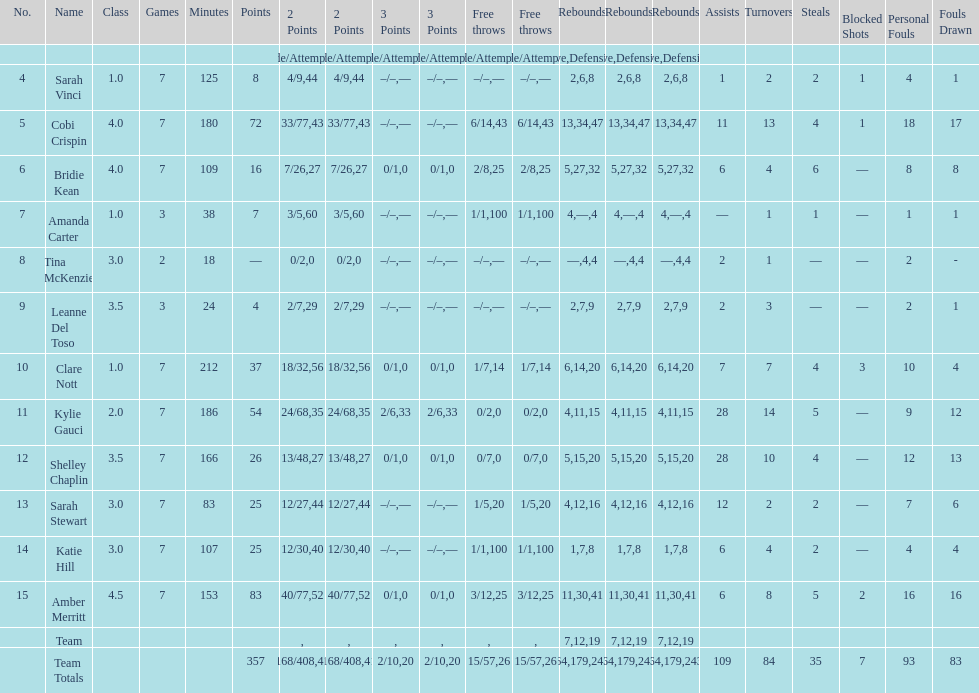Which player had the most total points? Amber Merritt. 